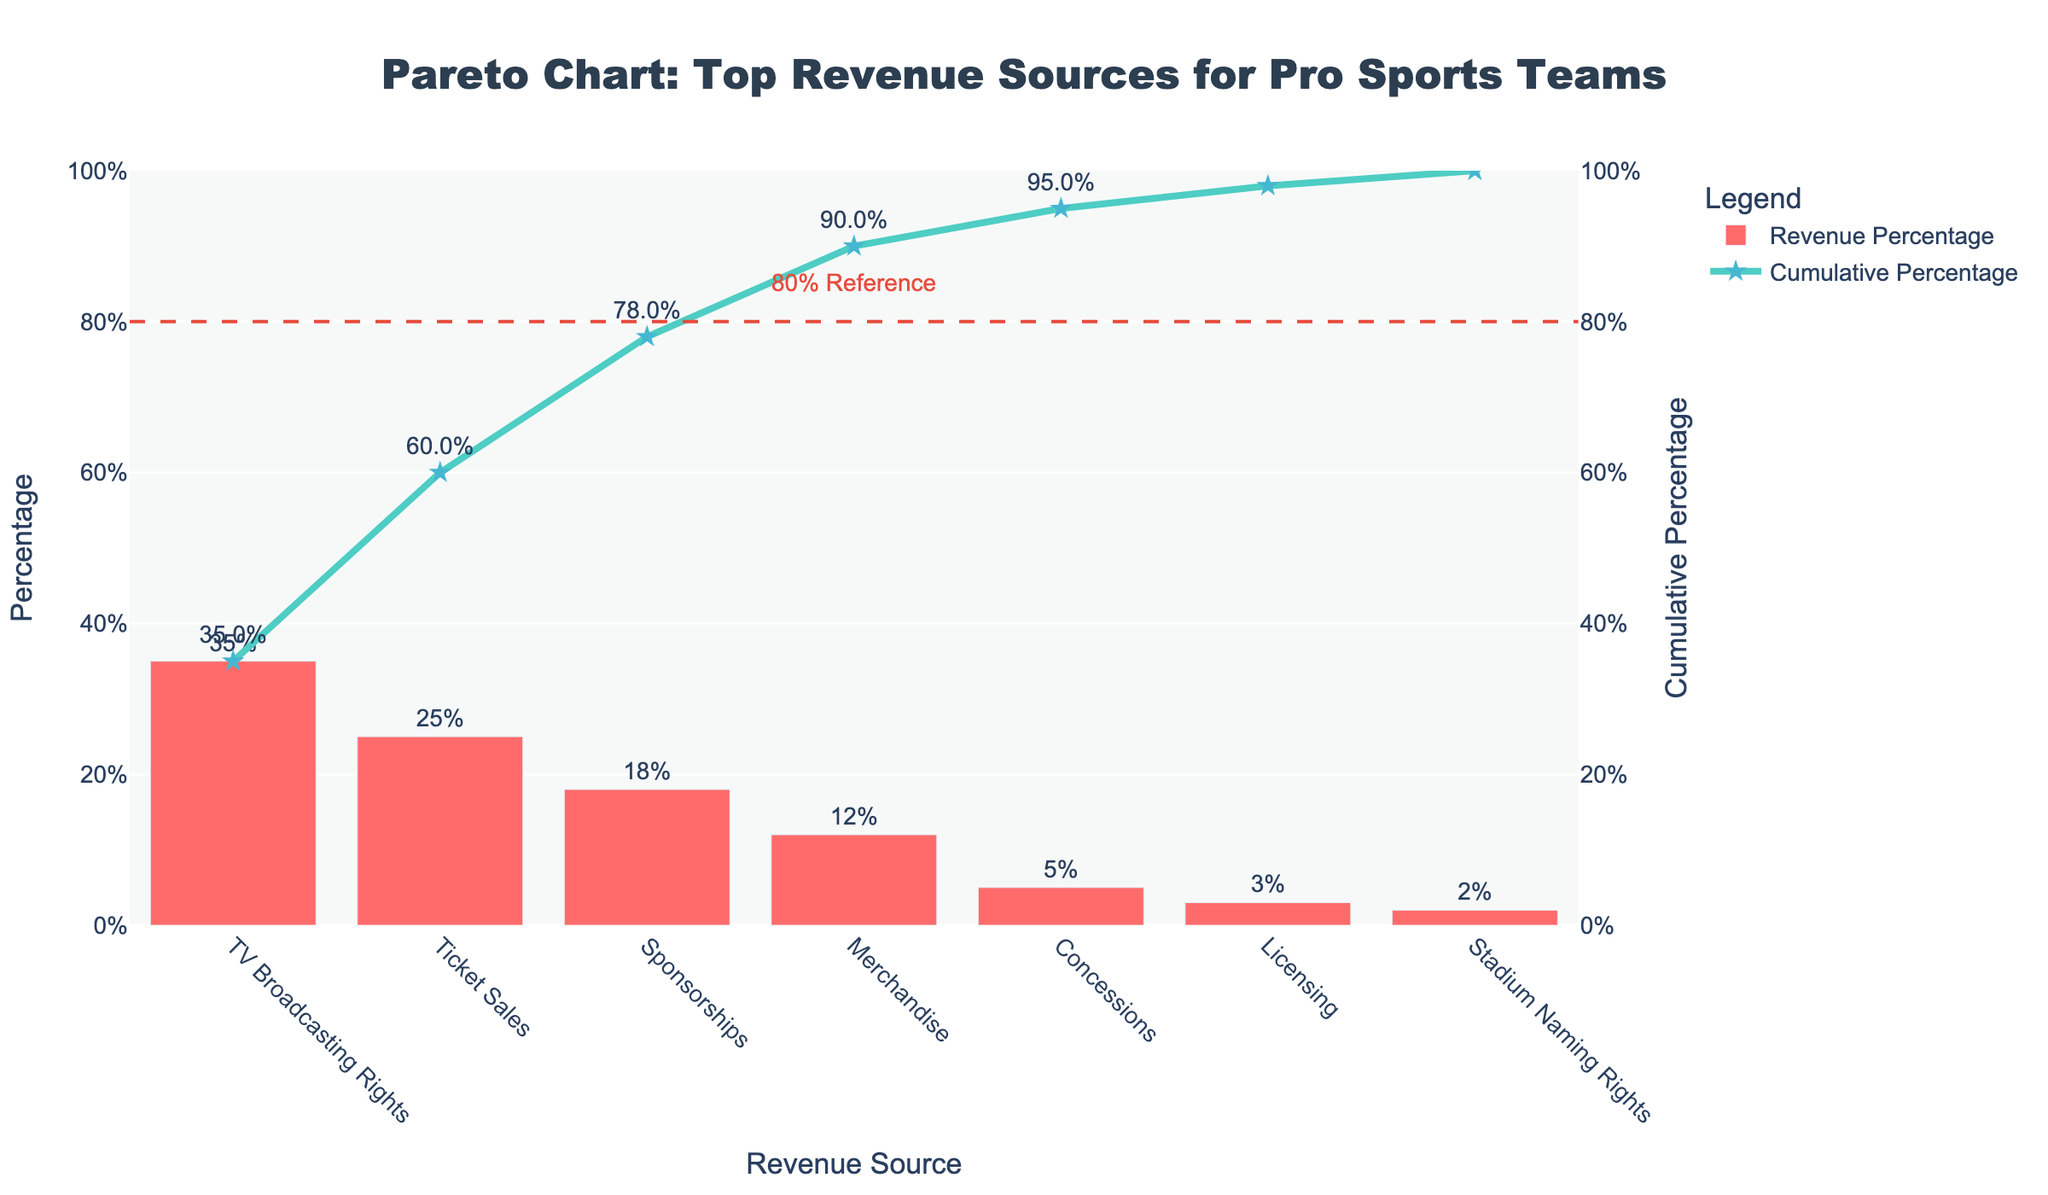What is the top source of revenue for professional sports teams by percentage? The "Revenue Source" axis shows different sources of revenue and their corresponding percentages. The highest bar represents TV Broadcasting Rights with a percentage of 35%.
Answer: TV Broadcasting Rights Which two revenue sources combined contribute exactly 60% to the total revenue? By looking at the "Revenue Source" axis and summing the percentages, TV Broadcasting Rights (35%) and Ticket Sales (25%) together add up to 60%.
Answer: TV Broadcasting Rights and Ticket Sales What is the cumulative percentage after the top three revenue sources? The cumulative percentage is indicated by the line chart. After the top three sources: TV Broadcasting Rights (35%), Ticket Sales (25%), and Sponsorships (18%), the cumulative percentage reaches 78%.
Answer: 78% How much of the total revenue is attributed to Merchandise and Concessions combined? By identifying the percentages for Merchandise (12%) and Concessions (5%) and summing them up, we get 17%.
Answer: 17% Which revenue source contributes the least to the total revenue and what is its percentage? The bar with the smallest height on the "Revenue Source" axis is for Stadium Naming Rights, contributing 2%.
Answer: Stadium Naming Rights, 2% What percentage of total revenue is covered by the top 4 sources? The top four sources and their percentages are TV Broadcasting Rights (35%), Ticket Sales (25%), Sponsorships (18%), and Merchandise (12%). Adding them gives 35% + 25% + 18% + 12% = 90%.
Answer: 90% Which revenue sources would you need to consider to surpass the 80% cumulative percentage mark? The line chart for the cumulative percentage shows that TV Broadcasting Rights (35%), Ticket Sales (25%), Sponsorships (18%), and Merchandise (12%) together sum up to 90%, surpassing the 80% mark.
Answer: TV Broadcasting Rights, Ticket Sales, Sponsorships, Merchandise Is the cumulative percentage graph linear or does it show changes in slope? The cumulative percentage graph shows changes in slope due to differences in percentages of each revenue source. The slope is steeper for higher percentage sources and less steep for smaller ones.
Answer: Changes in slope Which revenue source has the third highest contribution and what exactly is its value in percentage? By looking at the heights of the bars in descending order, Sponsorships is the third highest, contributing 18%.
Answer: Sponsorships, 18% 